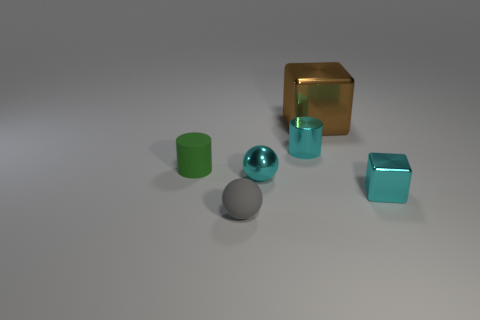How many other things are the same size as the brown metal block?
Give a very brief answer. 0. Is the small cube the same color as the small metallic cylinder?
Offer a very short reply. Yes. There is a small cylinder that is to the left of the thing that is in front of the shiny block in front of the small green matte thing; what is its color?
Provide a succinct answer. Green. How many cyan metallic objects are on the left side of the small object that is to the left of the small ball in front of the tiny cyan metallic cube?
Provide a short and direct response. 0. Is there anything else that has the same color as the tiny metallic block?
Your answer should be very brief. Yes. There is a cylinder that is in front of the metal cylinder; is its size the same as the tiny cyan ball?
Provide a short and direct response. Yes. What number of matte objects are left of the tiny shiny thing on the right side of the brown metallic thing?
Provide a succinct answer. 2. Are there any gray things that are to the right of the sphere right of the tiny sphere to the left of the cyan metal sphere?
Provide a short and direct response. No. Does the cyan cylinder have the same material as the tiny ball that is behind the cyan shiny block?
Your response must be concise. Yes. There is a rubber object that is behind the metal cube that is in front of the big thing; what is its shape?
Your answer should be compact. Cylinder. 